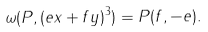Convert formula to latex. <formula><loc_0><loc_0><loc_500><loc_500>\omega ( P , ( e x + f y ) ^ { 3 } ) = P ( f , - e ) .</formula> 